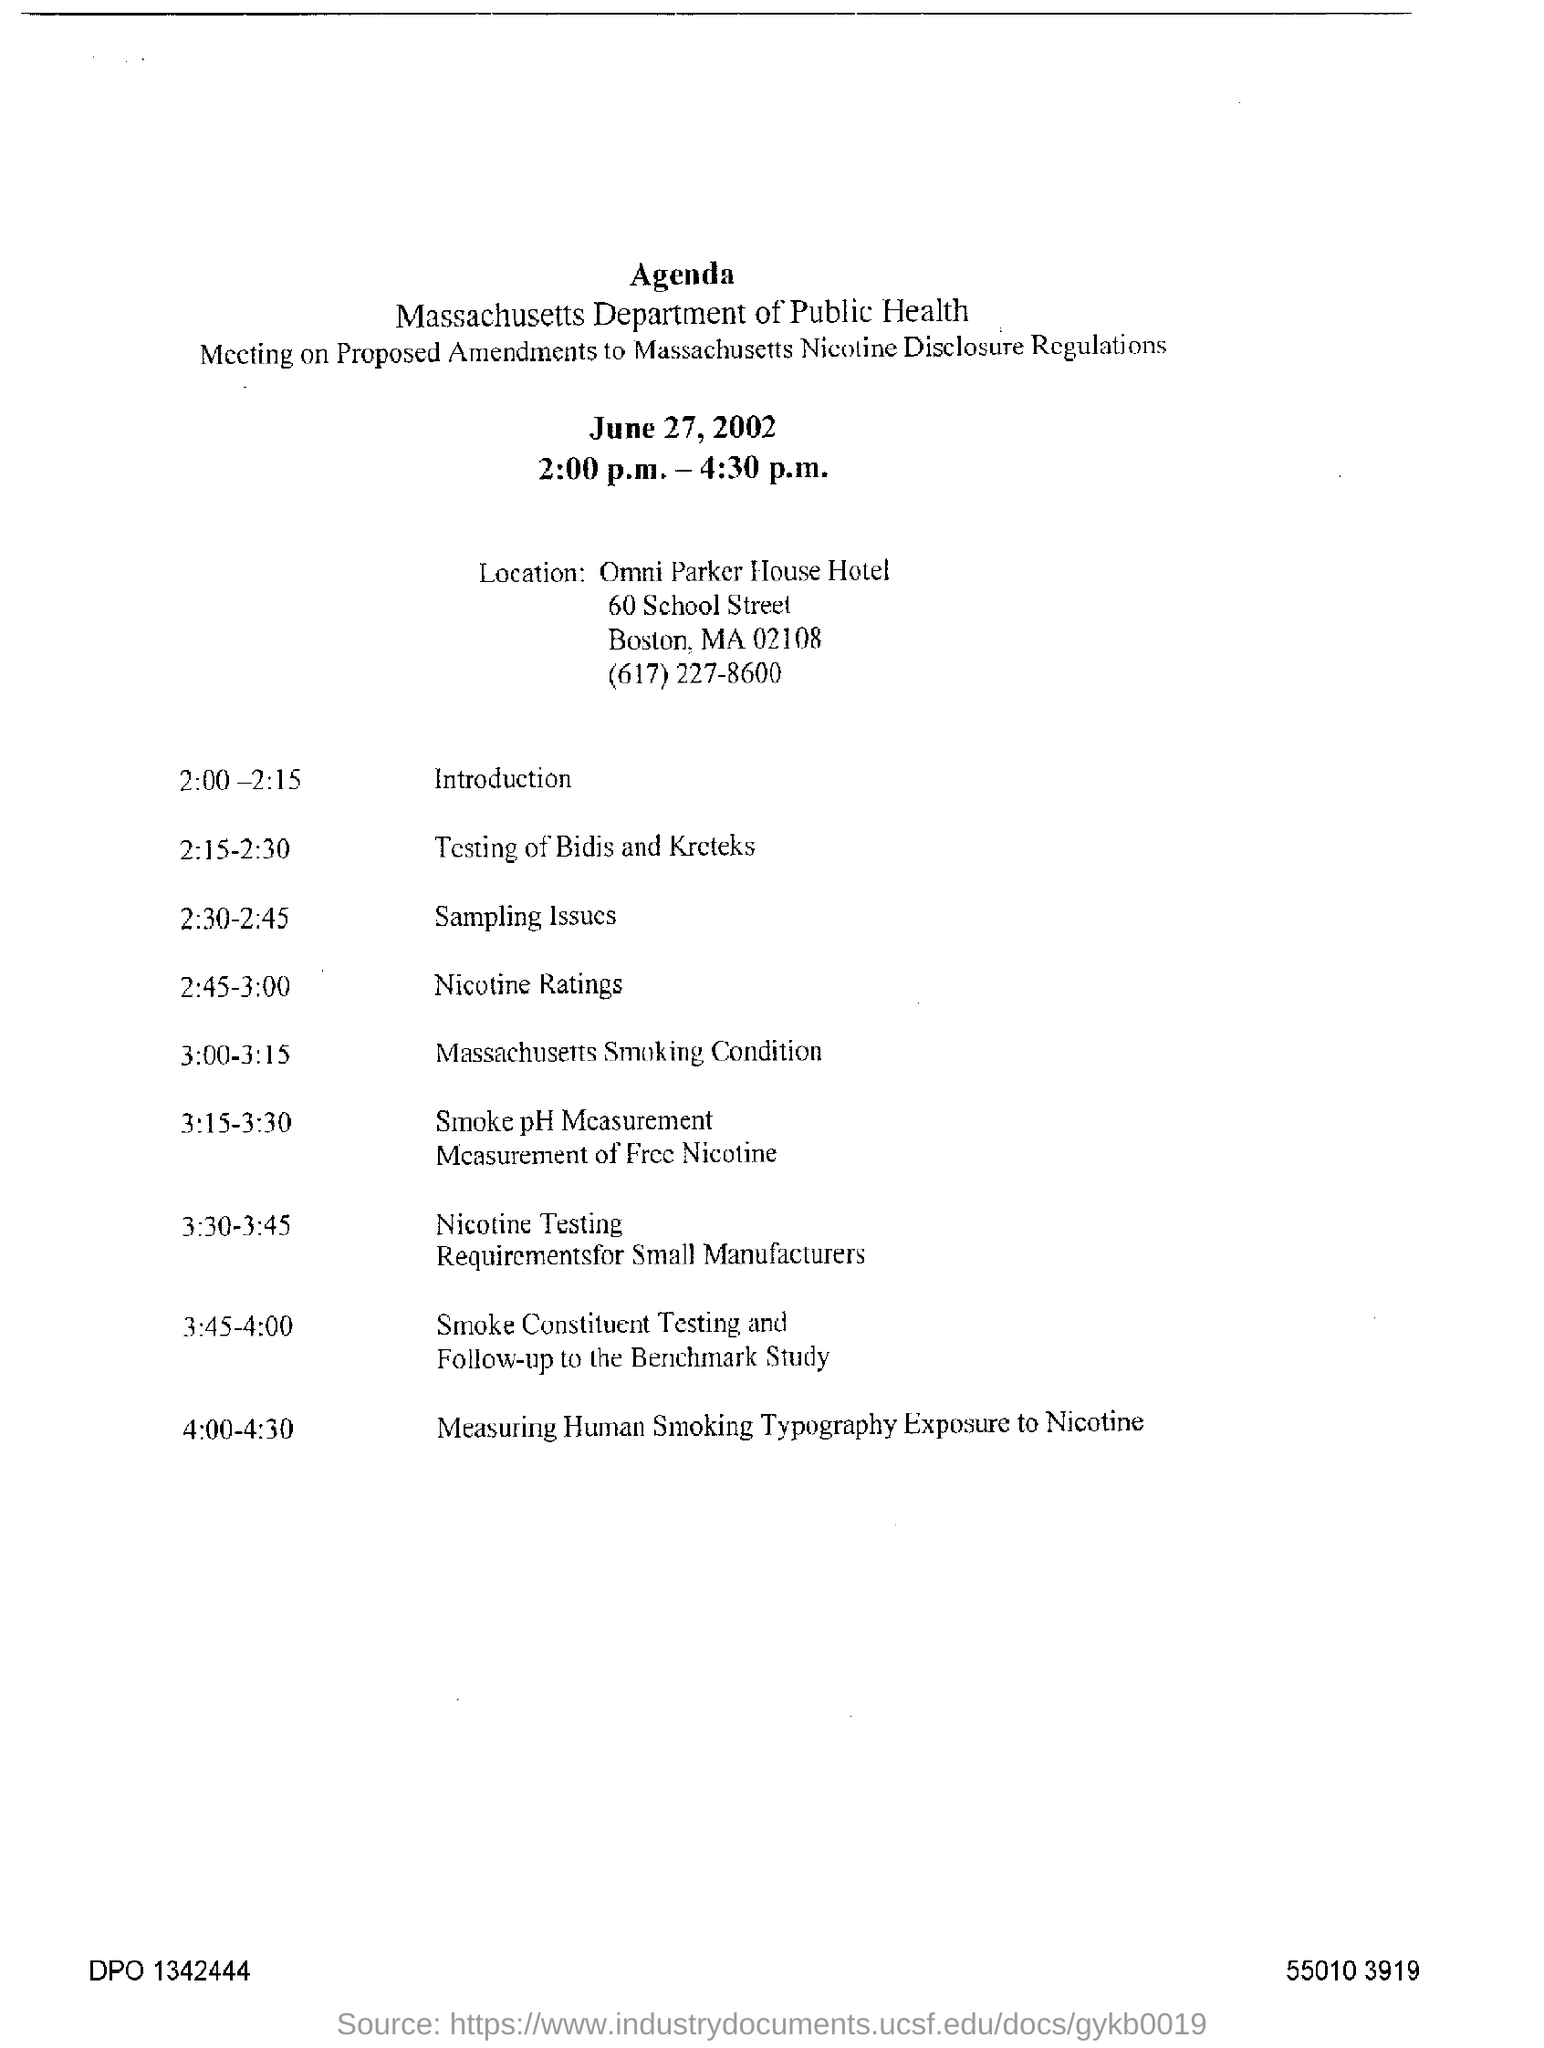List a handful of essential elements in this visual. The measuring of human smoking typography exposure to nicotine lasted for a period of 4:00-4:30. The contact number for the Massachusetts Department of Public Health is (617)227-8600. The Massachusetts Department of Public Health is the department responsible for promoting and protecting the health of the public in the state of Massachusetts. On June 27, 2002, a meeting was held to discuss proposed amendments. The location of the meeting is the Omni Parker House Hotel. 